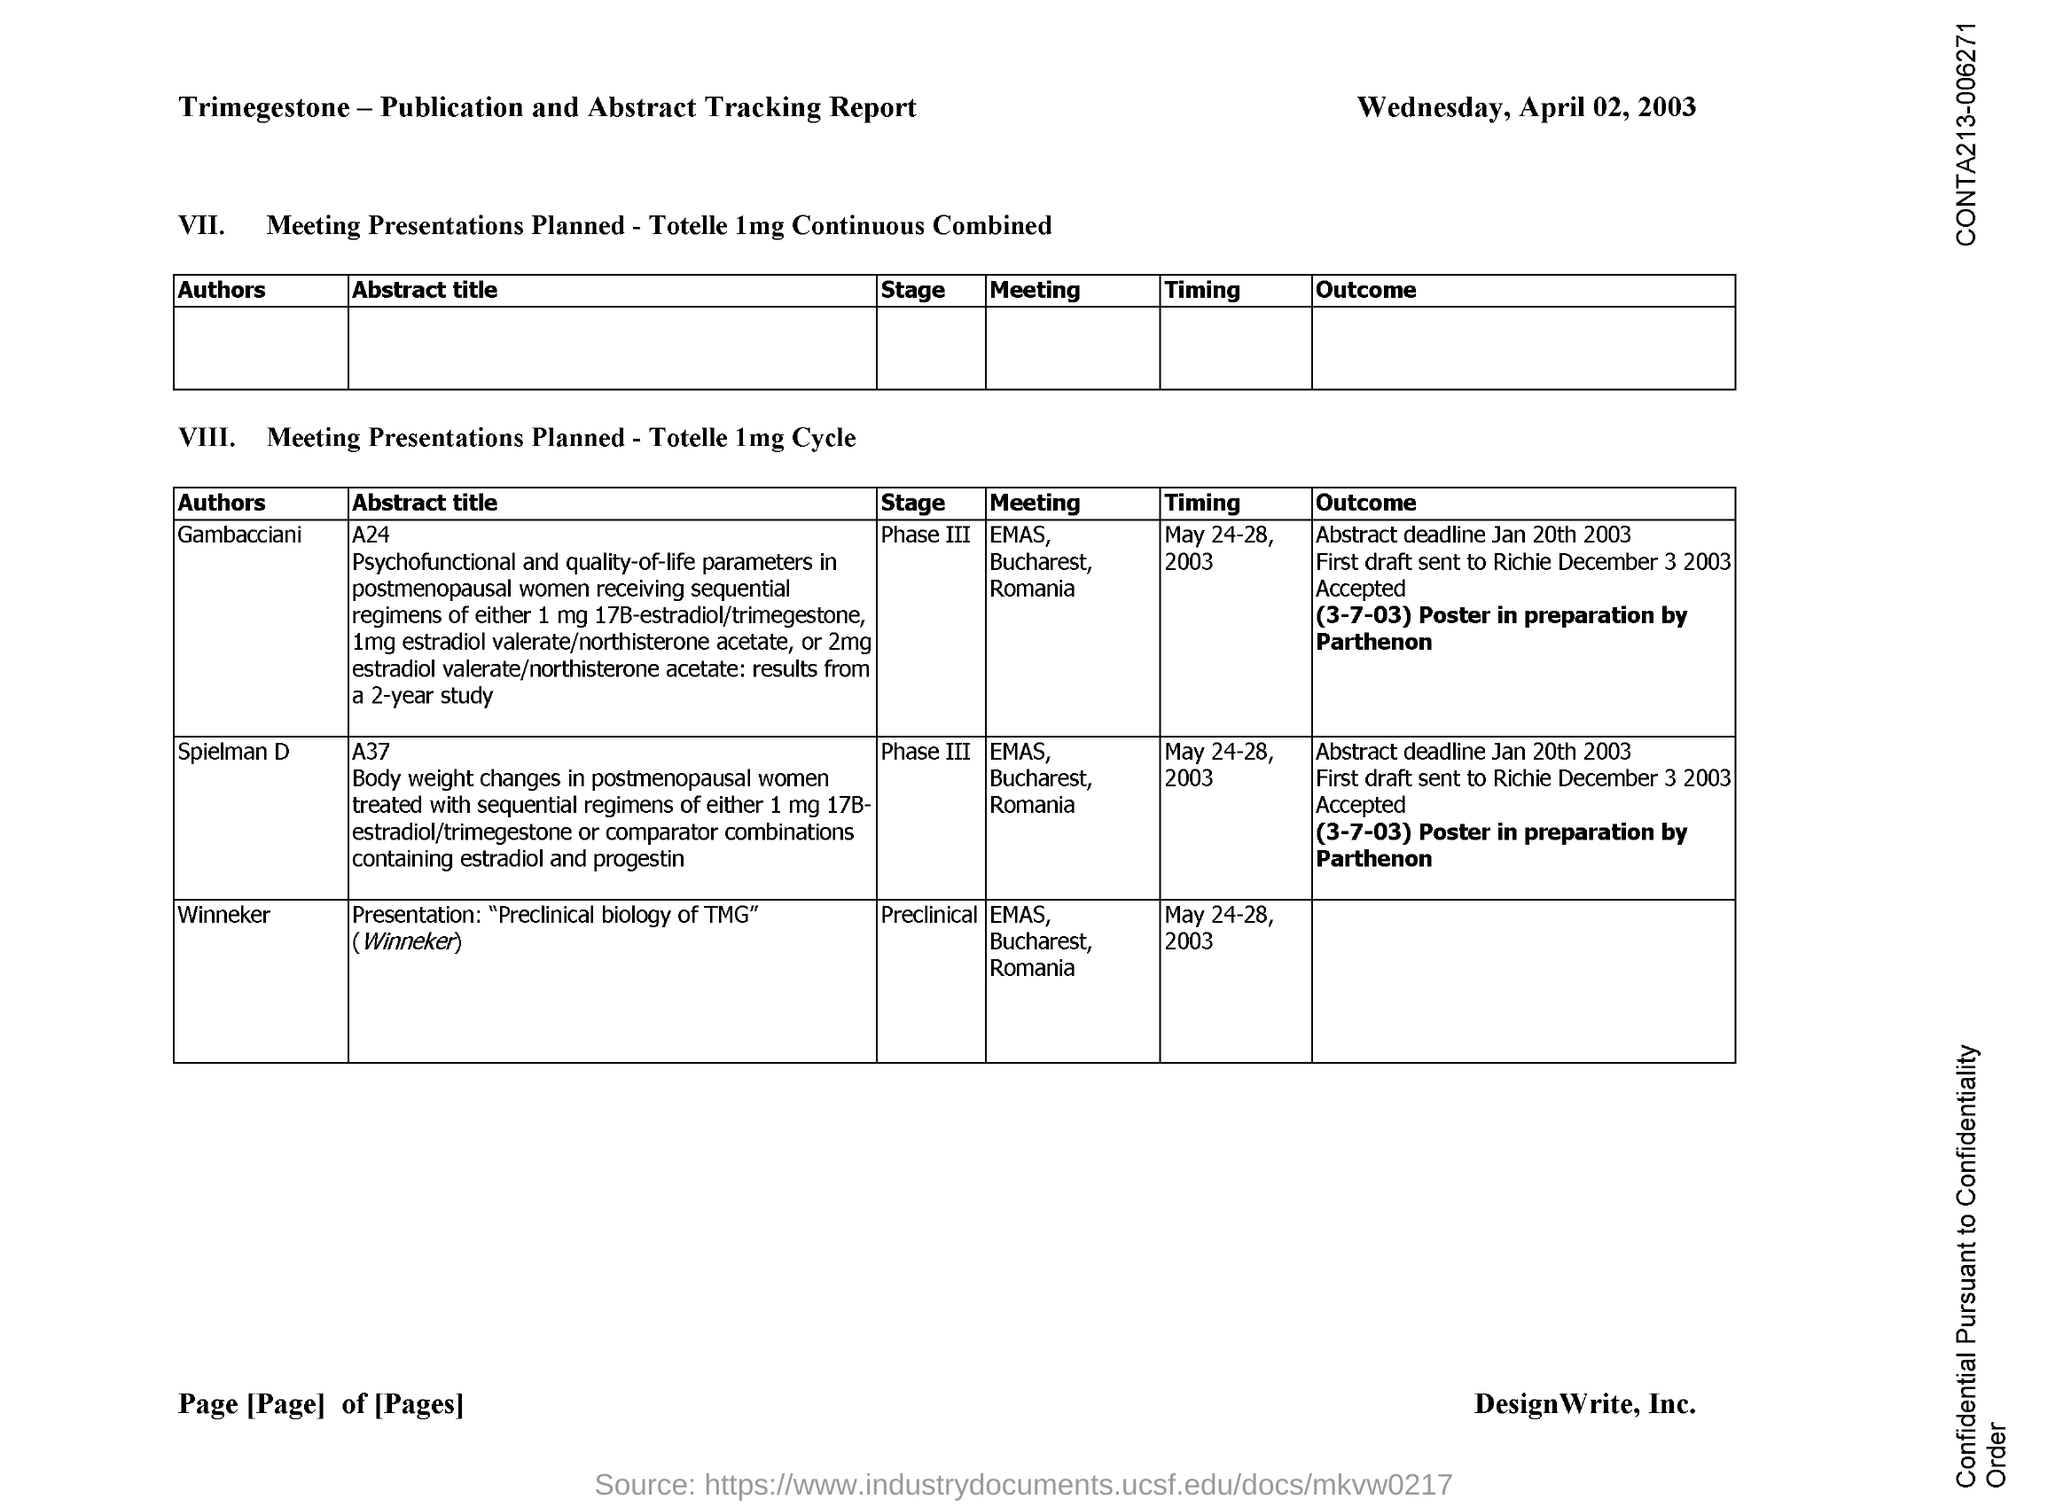What is the stage mentioned for author winneker ?
Your answer should be compact. Preclinical. 